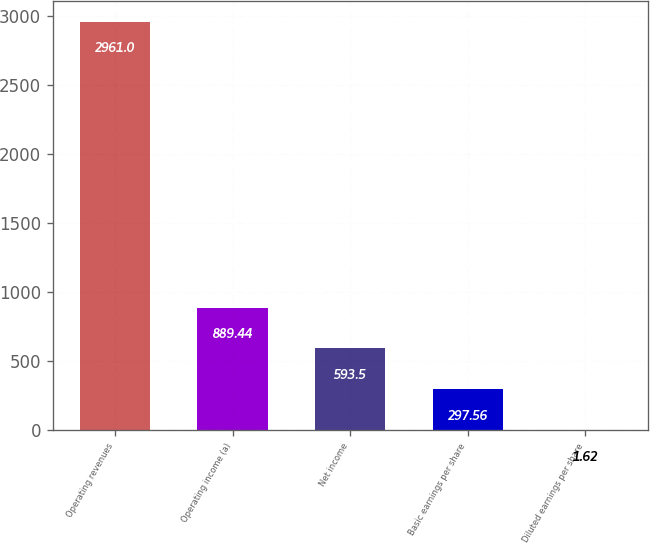Convert chart. <chart><loc_0><loc_0><loc_500><loc_500><bar_chart><fcel>Operating revenues<fcel>Operating income (a)<fcel>Net income<fcel>Basic earnings per share<fcel>Diluted earnings per share<nl><fcel>2961<fcel>889.44<fcel>593.5<fcel>297.56<fcel>1.62<nl></chart> 